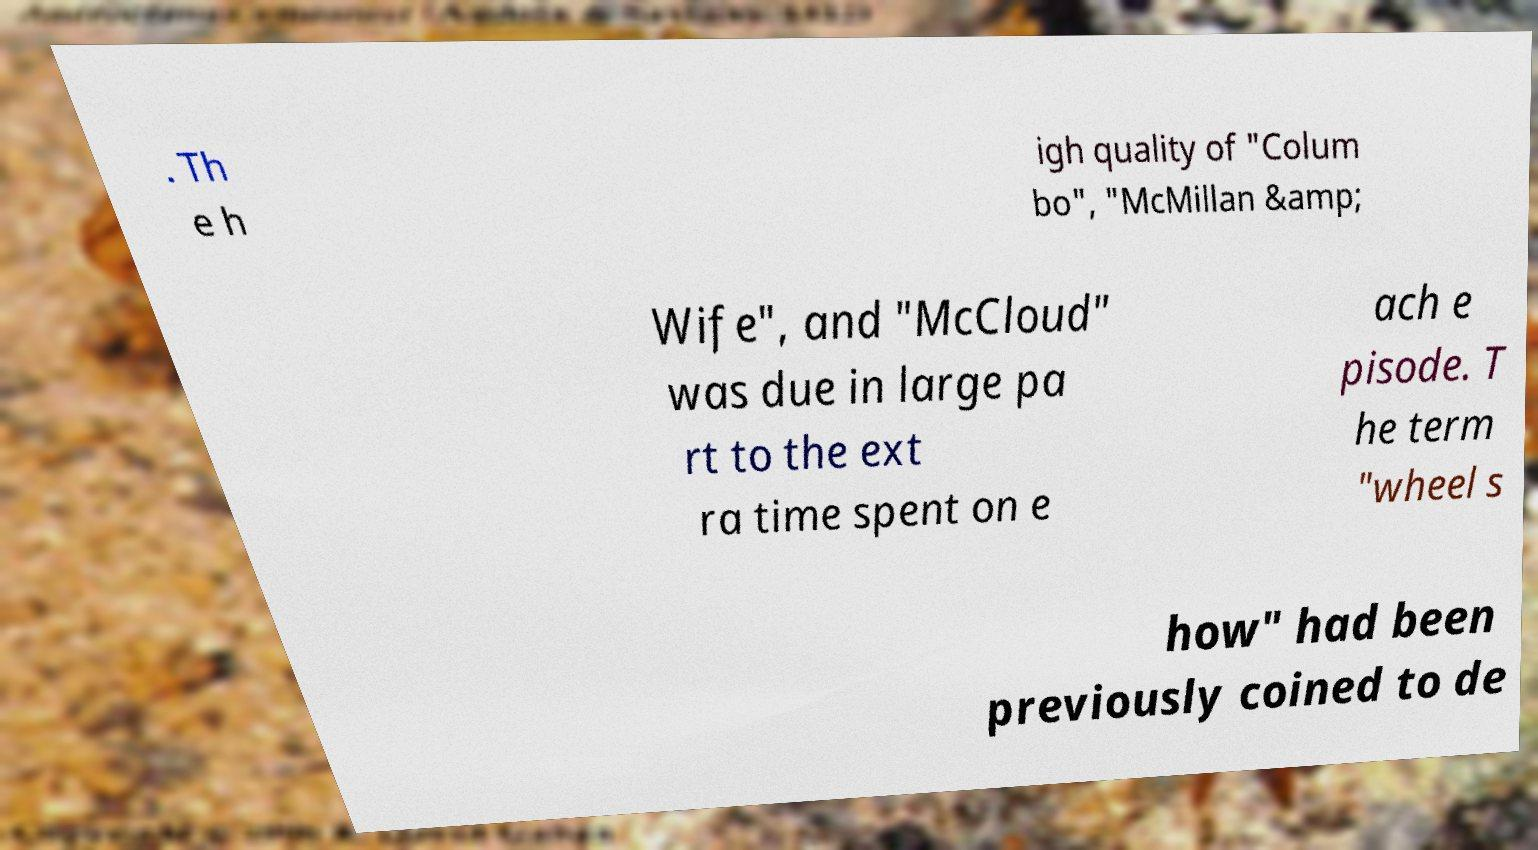For documentation purposes, I need the text within this image transcribed. Could you provide that? . Th e h igh quality of "Colum bo", "McMillan &amp; Wife", and "McCloud" was due in large pa rt to the ext ra time spent on e ach e pisode. T he term "wheel s how" had been previously coined to de 